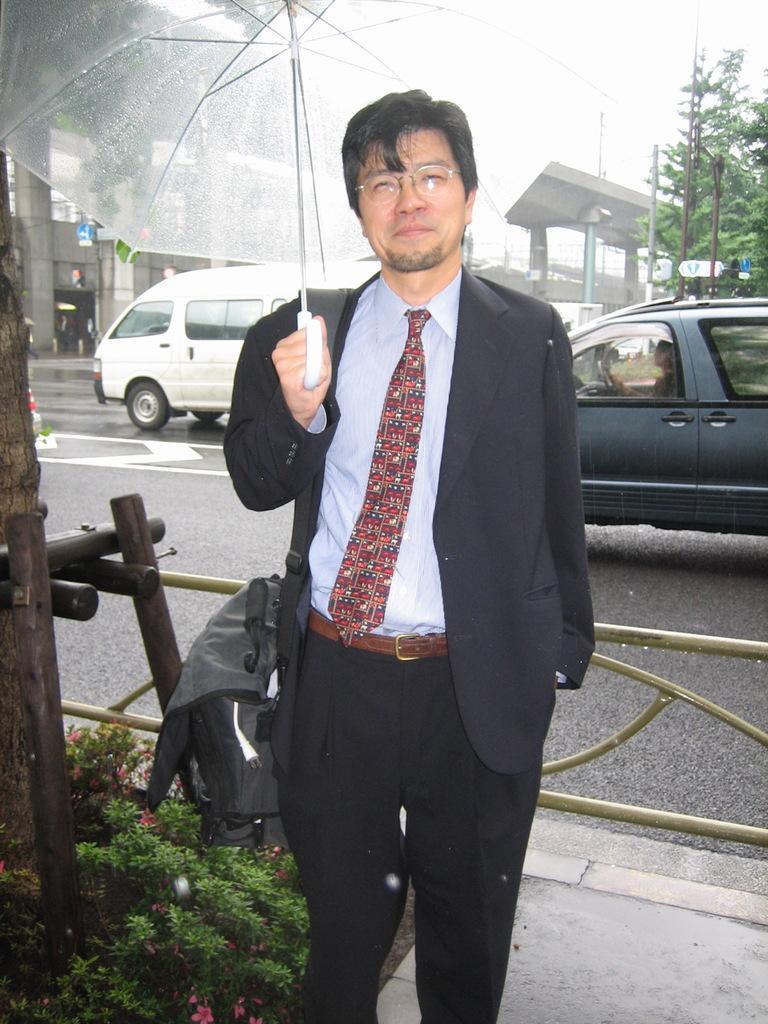Describe this image in one or two sentences. In this image we can see a person standing and holding an umbrella, behind him we can see the vehicles on the road, there are some poles, plants, pillars, trees and a bridge, also we can see the sky. 